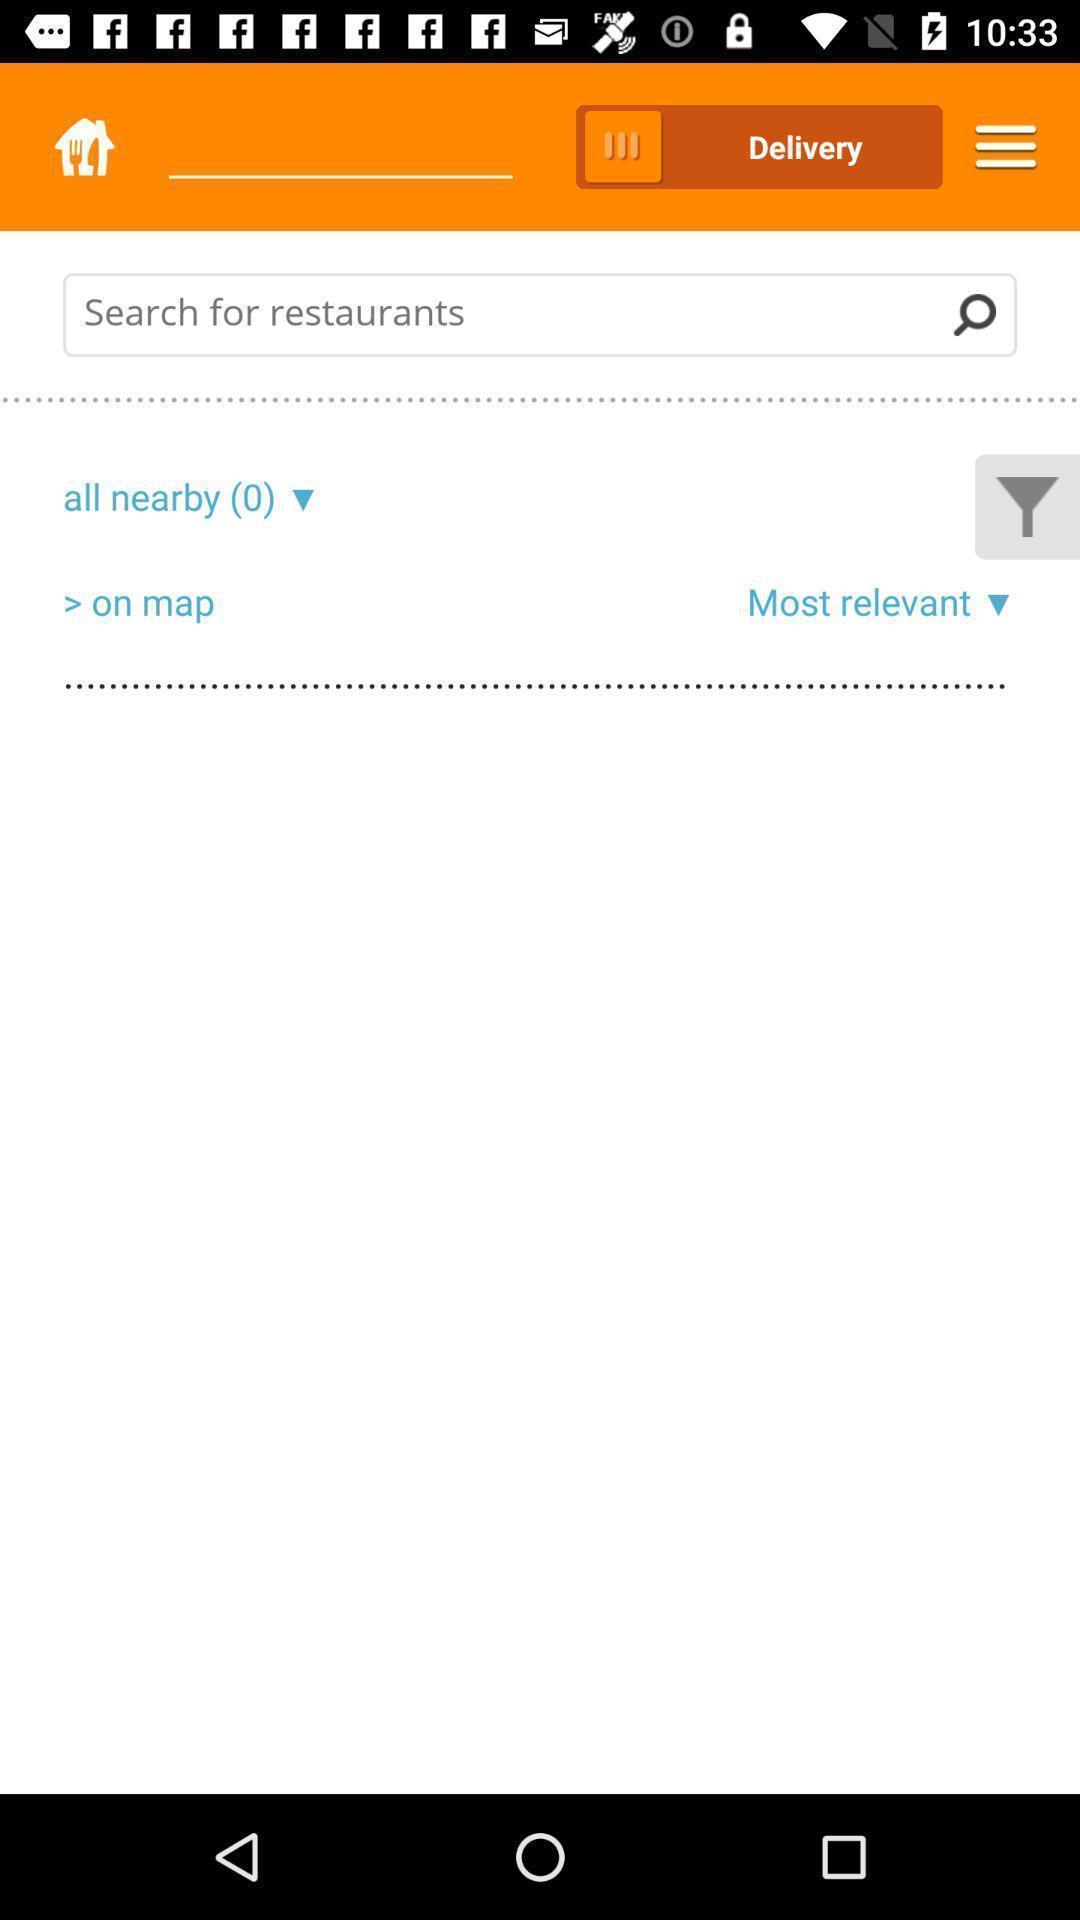Please provide a description for this image. Search page to find restaurant in a food delivery app. 